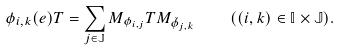Convert formula to latex. <formula><loc_0><loc_0><loc_500><loc_500>\phi _ { i , k } ( e ) T = \sum _ { j \in \mathbb { J } } M _ { \phi _ { i , j } } T M _ { \check { \phi } _ { j , k } } \quad ( ( i , k ) \in \mathbb { I } \times \mathbb { J } ) .</formula> 